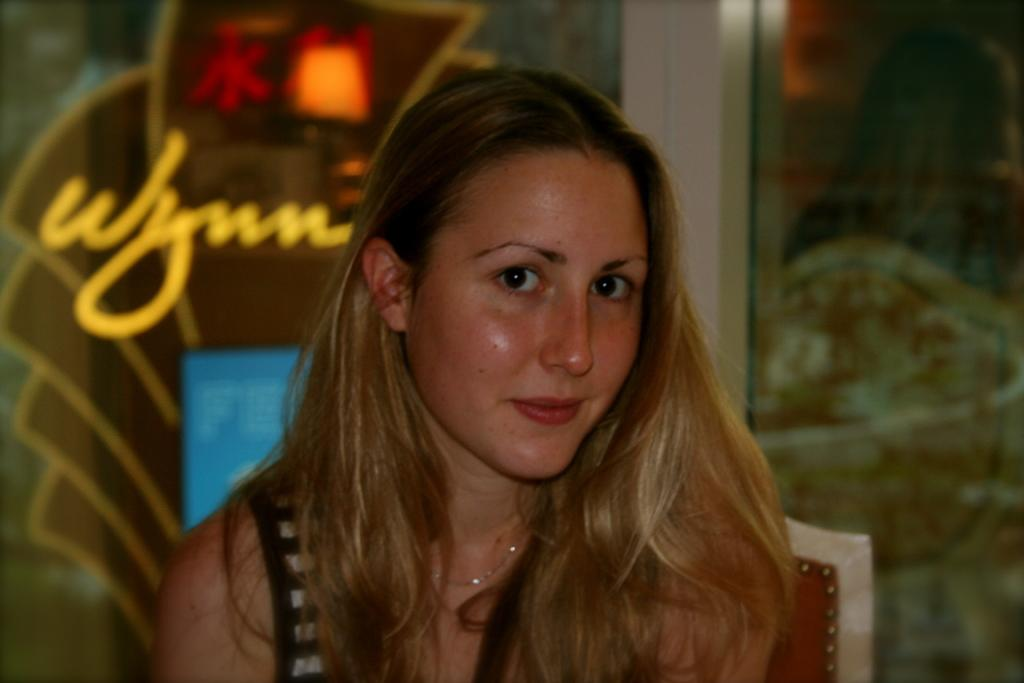Who is the main subject in the image? There is a girl in the image. What is the girl's expression in the image? The girl is smiling in the image. What is the girl looking at in the image? The girl is staring at something in the image. What type of goat can be seen in the image? There is no goat present in the image. What cast member is featured in the image? The image does not depict a cast member from a movie or show; it features a girl. 